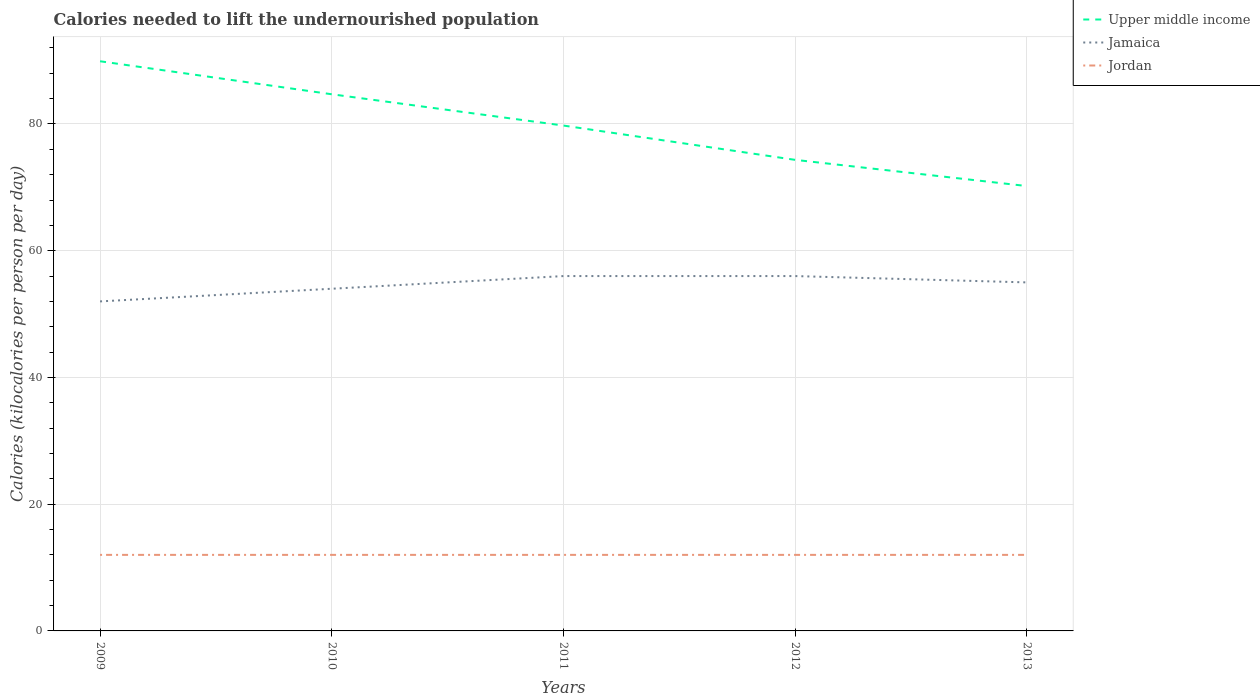How many different coloured lines are there?
Offer a terse response. 3. Is the number of lines equal to the number of legend labels?
Give a very brief answer. Yes. Across all years, what is the maximum total calories needed to lift the undernourished population in Upper middle income?
Your answer should be compact. 70.2. What is the total total calories needed to lift the undernourished population in Upper middle income in the graph?
Keep it short and to the point. 5.41. What is the difference between the highest and the second highest total calories needed to lift the undernourished population in Upper middle income?
Your response must be concise. 19.7. How many lines are there?
Your answer should be very brief. 3. How many years are there in the graph?
Provide a succinct answer. 5. Are the values on the major ticks of Y-axis written in scientific E-notation?
Your answer should be compact. No. Does the graph contain any zero values?
Ensure brevity in your answer.  No. Does the graph contain grids?
Your answer should be compact. Yes. How many legend labels are there?
Provide a short and direct response. 3. How are the legend labels stacked?
Your answer should be compact. Vertical. What is the title of the graph?
Ensure brevity in your answer.  Calories needed to lift the undernourished population. What is the label or title of the X-axis?
Keep it short and to the point. Years. What is the label or title of the Y-axis?
Offer a terse response. Calories (kilocalories per person per day). What is the Calories (kilocalories per person per day) of Upper middle income in 2009?
Provide a short and direct response. 89.9. What is the Calories (kilocalories per person per day) in Jamaica in 2009?
Provide a succinct answer. 52. What is the Calories (kilocalories per person per day) in Jordan in 2009?
Keep it short and to the point. 12. What is the Calories (kilocalories per person per day) in Upper middle income in 2010?
Offer a terse response. 84.69. What is the Calories (kilocalories per person per day) of Jordan in 2010?
Make the answer very short. 12. What is the Calories (kilocalories per person per day) of Upper middle income in 2011?
Ensure brevity in your answer.  79.75. What is the Calories (kilocalories per person per day) of Jordan in 2011?
Offer a very short reply. 12. What is the Calories (kilocalories per person per day) in Upper middle income in 2012?
Provide a succinct answer. 74.34. What is the Calories (kilocalories per person per day) in Jamaica in 2012?
Give a very brief answer. 56. What is the Calories (kilocalories per person per day) of Jordan in 2012?
Give a very brief answer. 12. What is the Calories (kilocalories per person per day) in Upper middle income in 2013?
Your answer should be compact. 70.2. Across all years, what is the maximum Calories (kilocalories per person per day) of Upper middle income?
Offer a very short reply. 89.9. Across all years, what is the maximum Calories (kilocalories per person per day) of Jamaica?
Make the answer very short. 56. Across all years, what is the maximum Calories (kilocalories per person per day) of Jordan?
Your response must be concise. 12. Across all years, what is the minimum Calories (kilocalories per person per day) of Upper middle income?
Offer a terse response. 70.2. Across all years, what is the minimum Calories (kilocalories per person per day) of Jamaica?
Provide a succinct answer. 52. Across all years, what is the minimum Calories (kilocalories per person per day) of Jordan?
Ensure brevity in your answer.  12. What is the total Calories (kilocalories per person per day) of Upper middle income in the graph?
Your response must be concise. 398.88. What is the total Calories (kilocalories per person per day) of Jamaica in the graph?
Offer a terse response. 273. What is the difference between the Calories (kilocalories per person per day) of Upper middle income in 2009 and that in 2010?
Make the answer very short. 5.21. What is the difference between the Calories (kilocalories per person per day) in Jordan in 2009 and that in 2010?
Your answer should be very brief. 0. What is the difference between the Calories (kilocalories per person per day) of Upper middle income in 2009 and that in 2011?
Provide a succinct answer. 10.15. What is the difference between the Calories (kilocalories per person per day) of Jamaica in 2009 and that in 2011?
Provide a short and direct response. -4. What is the difference between the Calories (kilocalories per person per day) in Upper middle income in 2009 and that in 2012?
Ensure brevity in your answer.  15.56. What is the difference between the Calories (kilocalories per person per day) of Jamaica in 2009 and that in 2012?
Keep it short and to the point. -4. What is the difference between the Calories (kilocalories per person per day) in Upper middle income in 2009 and that in 2013?
Your answer should be very brief. 19.7. What is the difference between the Calories (kilocalories per person per day) of Upper middle income in 2010 and that in 2011?
Provide a succinct answer. 4.94. What is the difference between the Calories (kilocalories per person per day) in Jamaica in 2010 and that in 2011?
Your response must be concise. -2. What is the difference between the Calories (kilocalories per person per day) of Upper middle income in 2010 and that in 2012?
Your response must be concise. 10.35. What is the difference between the Calories (kilocalories per person per day) in Jamaica in 2010 and that in 2012?
Offer a terse response. -2. What is the difference between the Calories (kilocalories per person per day) in Jordan in 2010 and that in 2012?
Your response must be concise. 0. What is the difference between the Calories (kilocalories per person per day) of Upper middle income in 2010 and that in 2013?
Offer a terse response. 14.49. What is the difference between the Calories (kilocalories per person per day) in Upper middle income in 2011 and that in 2012?
Offer a terse response. 5.41. What is the difference between the Calories (kilocalories per person per day) in Jordan in 2011 and that in 2012?
Keep it short and to the point. 0. What is the difference between the Calories (kilocalories per person per day) in Upper middle income in 2011 and that in 2013?
Ensure brevity in your answer.  9.55. What is the difference between the Calories (kilocalories per person per day) of Upper middle income in 2012 and that in 2013?
Give a very brief answer. 4.13. What is the difference between the Calories (kilocalories per person per day) of Jordan in 2012 and that in 2013?
Your response must be concise. 0. What is the difference between the Calories (kilocalories per person per day) of Upper middle income in 2009 and the Calories (kilocalories per person per day) of Jamaica in 2010?
Provide a succinct answer. 35.9. What is the difference between the Calories (kilocalories per person per day) of Upper middle income in 2009 and the Calories (kilocalories per person per day) of Jordan in 2010?
Offer a terse response. 77.9. What is the difference between the Calories (kilocalories per person per day) of Upper middle income in 2009 and the Calories (kilocalories per person per day) of Jamaica in 2011?
Make the answer very short. 33.9. What is the difference between the Calories (kilocalories per person per day) of Upper middle income in 2009 and the Calories (kilocalories per person per day) of Jordan in 2011?
Your answer should be compact. 77.9. What is the difference between the Calories (kilocalories per person per day) of Upper middle income in 2009 and the Calories (kilocalories per person per day) of Jamaica in 2012?
Provide a short and direct response. 33.9. What is the difference between the Calories (kilocalories per person per day) in Upper middle income in 2009 and the Calories (kilocalories per person per day) in Jordan in 2012?
Give a very brief answer. 77.9. What is the difference between the Calories (kilocalories per person per day) of Upper middle income in 2009 and the Calories (kilocalories per person per day) of Jamaica in 2013?
Offer a very short reply. 34.9. What is the difference between the Calories (kilocalories per person per day) in Upper middle income in 2009 and the Calories (kilocalories per person per day) in Jordan in 2013?
Provide a short and direct response. 77.9. What is the difference between the Calories (kilocalories per person per day) in Upper middle income in 2010 and the Calories (kilocalories per person per day) in Jamaica in 2011?
Offer a very short reply. 28.69. What is the difference between the Calories (kilocalories per person per day) in Upper middle income in 2010 and the Calories (kilocalories per person per day) in Jordan in 2011?
Your answer should be very brief. 72.69. What is the difference between the Calories (kilocalories per person per day) in Upper middle income in 2010 and the Calories (kilocalories per person per day) in Jamaica in 2012?
Offer a very short reply. 28.69. What is the difference between the Calories (kilocalories per person per day) of Upper middle income in 2010 and the Calories (kilocalories per person per day) of Jordan in 2012?
Your answer should be compact. 72.69. What is the difference between the Calories (kilocalories per person per day) of Upper middle income in 2010 and the Calories (kilocalories per person per day) of Jamaica in 2013?
Make the answer very short. 29.69. What is the difference between the Calories (kilocalories per person per day) in Upper middle income in 2010 and the Calories (kilocalories per person per day) in Jordan in 2013?
Your answer should be compact. 72.69. What is the difference between the Calories (kilocalories per person per day) in Jamaica in 2010 and the Calories (kilocalories per person per day) in Jordan in 2013?
Keep it short and to the point. 42. What is the difference between the Calories (kilocalories per person per day) in Upper middle income in 2011 and the Calories (kilocalories per person per day) in Jamaica in 2012?
Your response must be concise. 23.75. What is the difference between the Calories (kilocalories per person per day) in Upper middle income in 2011 and the Calories (kilocalories per person per day) in Jordan in 2012?
Ensure brevity in your answer.  67.75. What is the difference between the Calories (kilocalories per person per day) in Jamaica in 2011 and the Calories (kilocalories per person per day) in Jordan in 2012?
Give a very brief answer. 44. What is the difference between the Calories (kilocalories per person per day) of Upper middle income in 2011 and the Calories (kilocalories per person per day) of Jamaica in 2013?
Make the answer very short. 24.75. What is the difference between the Calories (kilocalories per person per day) in Upper middle income in 2011 and the Calories (kilocalories per person per day) in Jordan in 2013?
Give a very brief answer. 67.75. What is the difference between the Calories (kilocalories per person per day) in Jamaica in 2011 and the Calories (kilocalories per person per day) in Jordan in 2013?
Your response must be concise. 44. What is the difference between the Calories (kilocalories per person per day) in Upper middle income in 2012 and the Calories (kilocalories per person per day) in Jamaica in 2013?
Keep it short and to the point. 19.34. What is the difference between the Calories (kilocalories per person per day) in Upper middle income in 2012 and the Calories (kilocalories per person per day) in Jordan in 2013?
Ensure brevity in your answer.  62.34. What is the difference between the Calories (kilocalories per person per day) of Jamaica in 2012 and the Calories (kilocalories per person per day) of Jordan in 2013?
Ensure brevity in your answer.  44. What is the average Calories (kilocalories per person per day) in Upper middle income per year?
Give a very brief answer. 79.78. What is the average Calories (kilocalories per person per day) of Jamaica per year?
Give a very brief answer. 54.6. What is the average Calories (kilocalories per person per day) in Jordan per year?
Keep it short and to the point. 12. In the year 2009, what is the difference between the Calories (kilocalories per person per day) of Upper middle income and Calories (kilocalories per person per day) of Jamaica?
Offer a very short reply. 37.9. In the year 2009, what is the difference between the Calories (kilocalories per person per day) of Upper middle income and Calories (kilocalories per person per day) of Jordan?
Your answer should be very brief. 77.9. In the year 2010, what is the difference between the Calories (kilocalories per person per day) in Upper middle income and Calories (kilocalories per person per day) in Jamaica?
Provide a short and direct response. 30.69. In the year 2010, what is the difference between the Calories (kilocalories per person per day) of Upper middle income and Calories (kilocalories per person per day) of Jordan?
Give a very brief answer. 72.69. In the year 2011, what is the difference between the Calories (kilocalories per person per day) of Upper middle income and Calories (kilocalories per person per day) of Jamaica?
Provide a short and direct response. 23.75. In the year 2011, what is the difference between the Calories (kilocalories per person per day) of Upper middle income and Calories (kilocalories per person per day) of Jordan?
Your answer should be compact. 67.75. In the year 2012, what is the difference between the Calories (kilocalories per person per day) of Upper middle income and Calories (kilocalories per person per day) of Jamaica?
Make the answer very short. 18.34. In the year 2012, what is the difference between the Calories (kilocalories per person per day) in Upper middle income and Calories (kilocalories per person per day) in Jordan?
Keep it short and to the point. 62.34. In the year 2012, what is the difference between the Calories (kilocalories per person per day) in Jamaica and Calories (kilocalories per person per day) in Jordan?
Ensure brevity in your answer.  44. In the year 2013, what is the difference between the Calories (kilocalories per person per day) in Upper middle income and Calories (kilocalories per person per day) in Jamaica?
Offer a terse response. 15.2. In the year 2013, what is the difference between the Calories (kilocalories per person per day) in Upper middle income and Calories (kilocalories per person per day) in Jordan?
Your answer should be compact. 58.2. What is the ratio of the Calories (kilocalories per person per day) of Upper middle income in 2009 to that in 2010?
Your answer should be very brief. 1.06. What is the ratio of the Calories (kilocalories per person per day) of Jamaica in 2009 to that in 2010?
Give a very brief answer. 0.96. What is the ratio of the Calories (kilocalories per person per day) in Upper middle income in 2009 to that in 2011?
Provide a succinct answer. 1.13. What is the ratio of the Calories (kilocalories per person per day) of Jamaica in 2009 to that in 2011?
Provide a short and direct response. 0.93. What is the ratio of the Calories (kilocalories per person per day) of Jordan in 2009 to that in 2011?
Provide a succinct answer. 1. What is the ratio of the Calories (kilocalories per person per day) in Upper middle income in 2009 to that in 2012?
Offer a very short reply. 1.21. What is the ratio of the Calories (kilocalories per person per day) in Jamaica in 2009 to that in 2012?
Give a very brief answer. 0.93. What is the ratio of the Calories (kilocalories per person per day) in Upper middle income in 2009 to that in 2013?
Offer a terse response. 1.28. What is the ratio of the Calories (kilocalories per person per day) in Jamaica in 2009 to that in 2013?
Your response must be concise. 0.95. What is the ratio of the Calories (kilocalories per person per day) of Jordan in 2009 to that in 2013?
Make the answer very short. 1. What is the ratio of the Calories (kilocalories per person per day) in Upper middle income in 2010 to that in 2011?
Make the answer very short. 1.06. What is the ratio of the Calories (kilocalories per person per day) in Jamaica in 2010 to that in 2011?
Offer a very short reply. 0.96. What is the ratio of the Calories (kilocalories per person per day) of Upper middle income in 2010 to that in 2012?
Offer a very short reply. 1.14. What is the ratio of the Calories (kilocalories per person per day) of Jordan in 2010 to that in 2012?
Your answer should be compact. 1. What is the ratio of the Calories (kilocalories per person per day) in Upper middle income in 2010 to that in 2013?
Ensure brevity in your answer.  1.21. What is the ratio of the Calories (kilocalories per person per day) in Jamaica in 2010 to that in 2013?
Your answer should be compact. 0.98. What is the ratio of the Calories (kilocalories per person per day) of Upper middle income in 2011 to that in 2012?
Ensure brevity in your answer.  1.07. What is the ratio of the Calories (kilocalories per person per day) of Jamaica in 2011 to that in 2012?
Ensure brevity in your answer.  1. What is the ratio of the Calories (kilocalories per person per day) in Jordan in 2011 to that in 2012?
Make the answer very short. 1. What is the ratio of the Calories (kilocalories per person per day) in Upper middle income in 2011 to that in 2013?
Provide a succinct answer. 1.14. What is the ratio of the Calories (kilocalories per person per day) in Jamaica in 2011 to that in 2013?
Provide a succinct answer. 1.02. What is the ratio of the Calories (kilocalories per person per day) in Upper middle income in 2012 to that in 2013?
Your response must be concise. 1.06. What is the ratio of the Calories (kilocalories per person per day) of Jamaica in 2012 to that in 2013?
Offer a terse response. 1.02. What is the ratio of the Calories (kilocalories per person per day) in Jordan in 2012 to that in 2013?
Give a very brief answer. 1. What is the difference between the highest and the second highest Calories (kilocalories per person per day) of Upper middle income?
Provide a succinct answer. 5.21. What is the difference between the highest and the second highest Calories (kilocalories per person per day) in Jamaica?
Give a very brief answer. 0. What is the difference between the highest and the second highest Calories (kilocalories per person per day) in Jordan?
Offer a terse response. 0. What is the difference between the highest and the lowest Calories (kilocalories per person per day) in Upper middle income?
Provide a short and direct response. 19.7. What is the difference between the highest and the lowest Calories (kilocalories per person per day) of Jordan?
Make the answer very short. 0. 